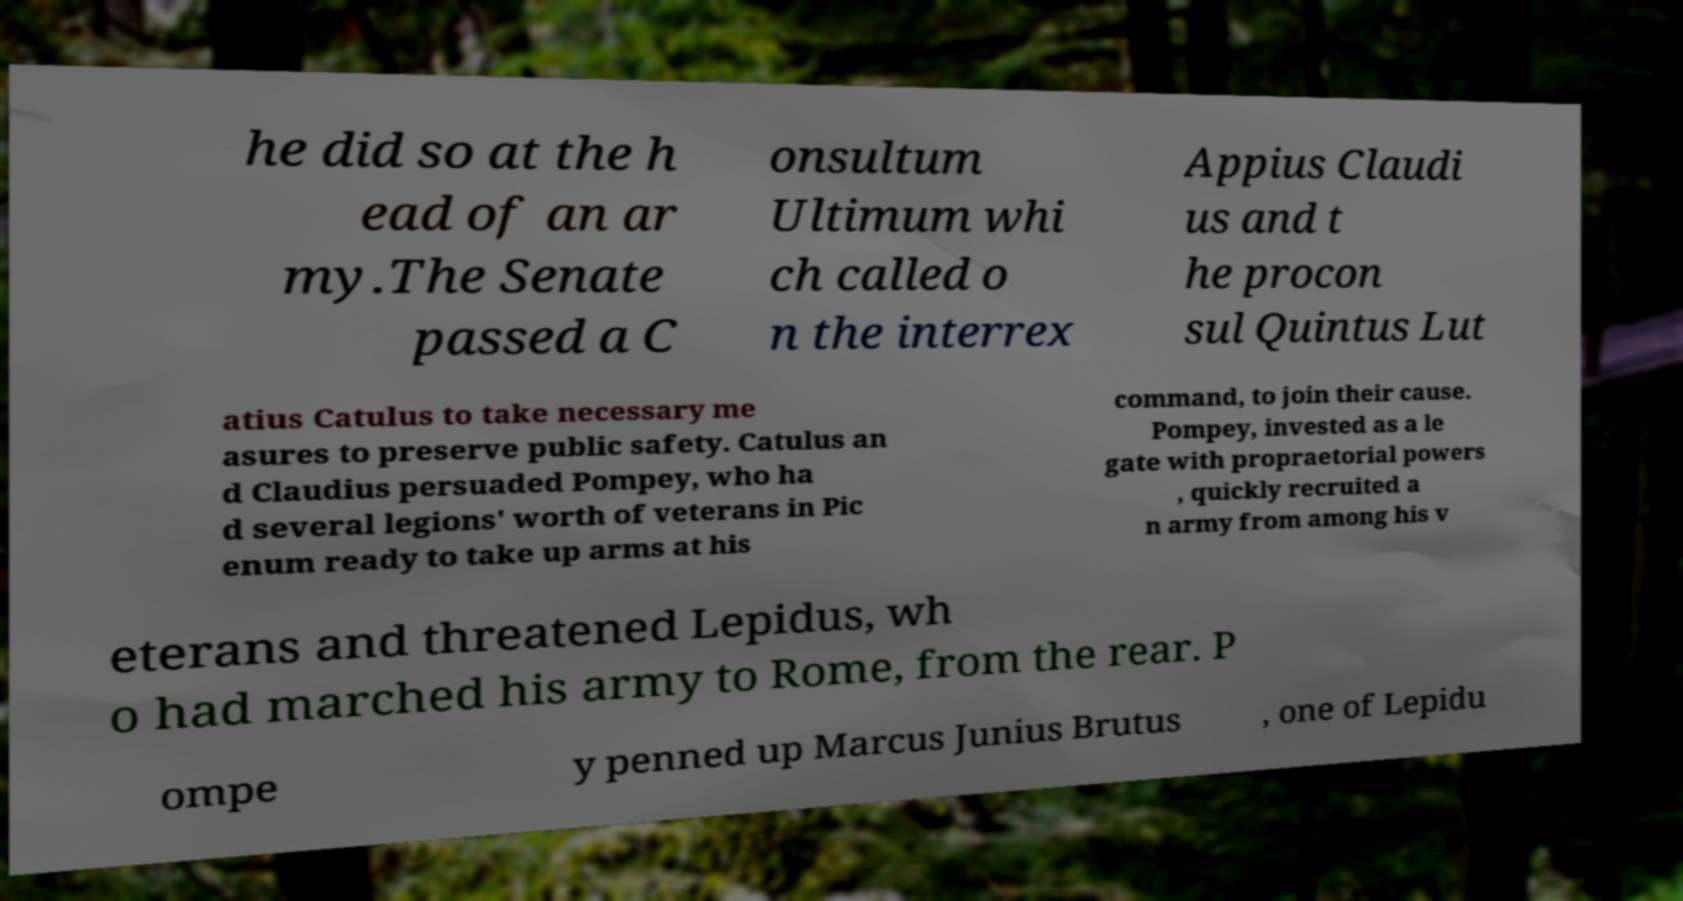Can you accurately transcribe the text from the provided image for me? he did so at the h ead of an ar my.The Senate passed a C onsultum Ultimum whi ch called o n the interrex Appius Claudi us and t he procon sul Quintus Lut atius Catulus to take necessary me asures to preserve public safety. Catulus an d Claudius persuaded Pompey, who ha d several legions' worth of veterans in Pic enum ready to take up arms at his command, to join their cause. Pompey, invested as a le gate with propraetorial powers , quickly recruited a n army from among his v eterans and threatened Lepidus, wh o had marched his army to Rome, from the rear. P ompe y penned up Marcus Junius Brutus , one of Lepidu 